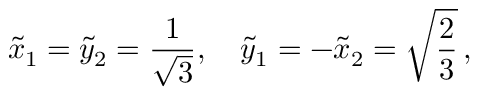Convert formula to latex. <formula><loc_0><loc_0><loc_500><loc_500>\tilde { x } _ { 1 } = \tilde { y } _ { 2 } = \frac { 1 } { \sqrt { 3 } } , \quad \tilde { y } _ { 1 } = - \tilde { x } _ { 2 } = \sqrt { \frac { 2 } { 3 } } \, ,</formula> 